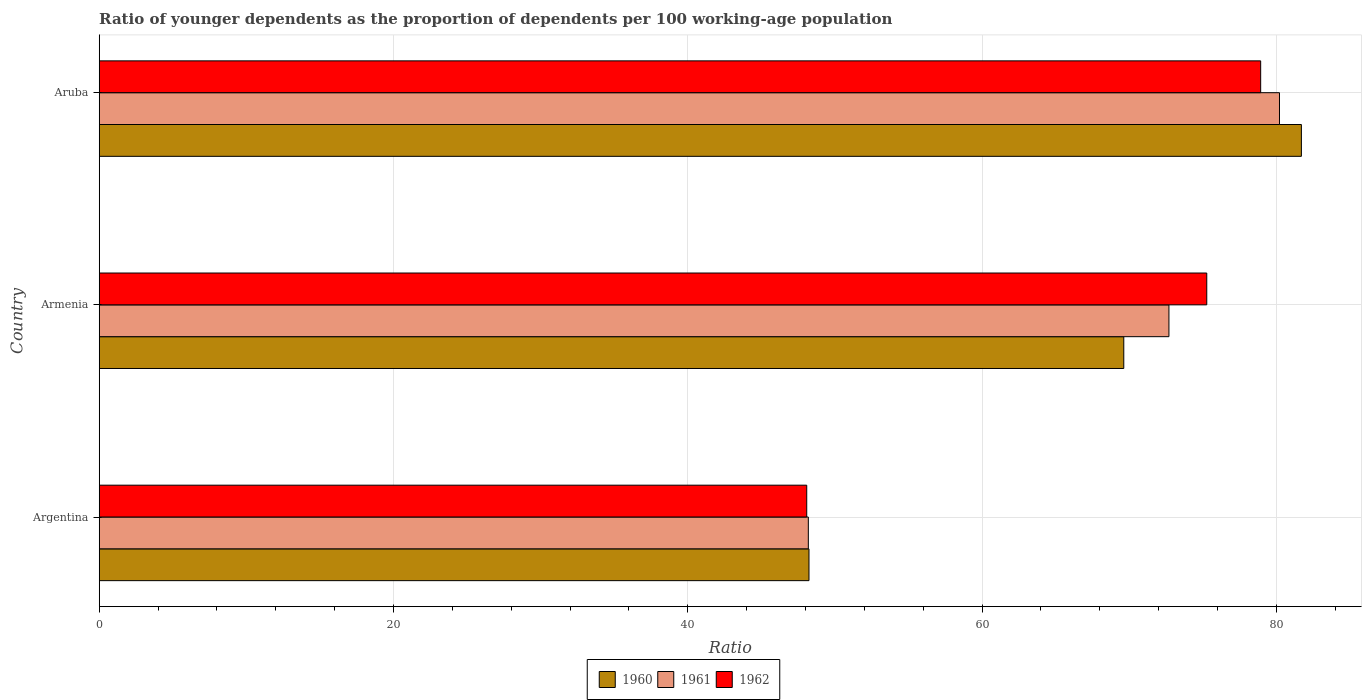How many groups of bars are there?
Your answer should be compact. 3. Are the number of bars on each tick of the Y-axis equal?
Provide a short and direct response. Yes. What is the label of the 3rd group of bars from the top?
Offer a very short reply. Argentina. In how many cases, is the number of bars for a given country not equal to the number of legend labels?
Keep it short and to the point. 0. What is the age dependency ratio(young) in 1962 in Argentina?
Offer a terse response. 48.09. Across all countries, what is the maximum age dependency ratio(young) in 1960?
Ensure brevity in your answer.  81.7. Across all countries, what is the minimum age dependency ratio(young) in 1961?
Your response must be concise. 48.19. In which country was the age dependency ratio(young) in 1961 maximum?
Give a very brief answer. Aruba. What is the total age dependency ratio(young) in 1960 in the graph?
Ensure brevity in your answer.  199.57. What is the difference between the age dependency ratio(young) in 1960 in Argentina and that in Aruba?
Ensure brevity in your answer.  -33.46. What is the difference between the age dependency ratio(young) in 1962 in Argentina and the age dependency ratio(young) in 1961 in Aruba?
Offer a terse response. -32.13. What is the average age dependency ratio(young) in 1961 per country?
Your answer should be very brief. 67.04. What is the difference between the age dependency ratio(young) in 1961 and age dependency ratio(young) in 1962 in Armenia?
Offer a terse response. -2.57. In how many countries, is the age dependency ratio(young) in 1961 greater than 68 ?
Give a very brief answer. 2. What is the ratio of the age dependency ratio(young) in 1961 in Argentina to that in Armenia?
Your response must be concise. 0.66. Is the age dependency ratio(young) in 1961 in Argentina less than that in Armenia?
Your response must be concise. Yes. Is the difference between the age dependency ratio(young) in 1961 in Argentina and Aruba greater than the difference between the age dependency ratio(young) in 1962 in Argentina and Aruba?
Keep it short and to the point. No. What is the difference between the highest and the second highest age dependency ratio(young) in 1960?
Provide a short and direct response. 12.07. What is the difference between the highest and the lowest age dependency ratio(young) in 1962?
Give a very brief answer. 30.85. Is the sum of the age dependency ratio(young) in 1962 in Argentina and Armenia greater than the maximum age dependency ratio(young) in 1960 across all countries?
Provide a succinct answer. Yes. What does the 3rd bar from the top in Argentina represents?
Offer a terse response. 1960. How many bars are there?
Your answer should be compact. 9. Are all the bars in the graph horizontal?
Your response must be concise. Yes. Does the graph contain any zero values?
Your answer should be compact. No. Where does the legend appear in the graph?
Your answer should be very brief. Bottom center. How are the legend labels stacked?
Give a very brief answer. Horizontal. What is the title of the graph?
Keep it short and to the point. Ratio of younger dependents as the proportion of dependents per 100 working-age population. Does "1994" appear as one of the legend labels in the graph?
Offer a very short reply. No. What is the label or title of the X-axis?
Offer a very short reply. Ratio. What is the label or title of the Y-axis?
Make the answer very short. Country. What is the Ratio of 1960 in Argentina?
Keep it short and to the point. 48.24. What is the Ratio of 1961 in Argentina?
Your response must be concise. 48.19. What is the Ratio of 1962 in Argentina?
Provide a succinct answer. 48.09. What is the Ratio in 1960 in Armenia?
Your answer should be very brief. 69.63. What is the Ratio of 1961 in Armenia?
Make the answer very short. 72.7. What is the Ratio of 1962 in Armenia?
Provide a succinct answer. 75.27. What is the Ratio of 1960 in Aruba?
Give a very brief answer. 81.7. What is the Ratio of 1961 in Aruba?
Your response must be concise. 80.21. What is the Ratio of 1962 in Aruba?
Make the answer very short. 78.94. Across all countries, what is the maximum Ratio in 1960?
Offer a very short reply. 81.7. Across all countries, what is the maximum Ratio in 1961?
Provide a short and direct response. 80.21. Across all countries, what is the maximum Ratio in 1962?
Your answer should be compact. 78.94. Across all countries, what is the minimum Ratio in 1960?
Ensure brevity in your answer.  48.24. Across all countries, what is the minimum Ratio in 1961?
Offer a terse response. 48.19. Across all countries, what is the minimum Ratio of 1962?
Provide a short and direct response. 48.09. What is the total Ratio of 1960 in the graph?
Offer a very short reply. 199.57. What is the total Ratio of 1961 in the graph?
Ensure brevity in your answer.  201.11. What is the total Ratio in 1962 in the graph?
Make the answer very short. 202.29. What is the difference between the Ratio in 1960 in Argentina and that in Armenia?
Offer a very short reply. -21.39. What is the difference between the Ratio of 1961 in Argentina and that in Armenia?
Make the answer very short. -24.51. What is the difference between the Ratio of 1962 in Argentina and that in Armenia?
Provide a succinct answer. -27.19. What is the difference between the Ratio in 1960 in Argentina and that in Aruba?
Ensure brevity in your answer.  -33.46. What is the difference between the Ratio of 1961 in Argentina and that in Aruba?
Provide a short and direct response. -32.02. What is the difference between the Ratio in 1962 in Argentina and that in Aruba?
Ensure brevity in your answer.  -30.85. What is the difference between the Ratio in 1960 in Armenia and that in Aruba?
Offer a terse response. -12.07. What is the difference between the Ratio in 1961 in Armenia and that in Aruba?
Keep it short and to the point. -7.51. What is the difference between the Ratio of 1962 in Armenia and that in Aruba?
Provide a short and direct response. -3.66. What is the difference between the Ratio of 1960 in Argentina and the Ratio of 1961 in Armenia?
Keep it short and to the point. -24.46. What is the difference between the Ratio of 1960 in Argentina and the Ratio of 1962 in Armenia?
Your answer should be very brief. -27.03. What is the difference between the Ratio in 1961 in Argentina and the Ratio in 1962 in Armenia?
Ensure brevity in your answer.  -27.08. What is the difference between the Ratio of 1960 in Argentina and the Ratio of 1961 in Aruba?
Keep it short and to the point. -31.98. What is the difference between the Ratio in 1960 in Argentina and the Ratio in 1962 in Aruba?
Your answer should be very brief. -30.7. What is the difference between the Ratio in 1961 in Argentina and the Ratio in 1962 in Aruba?
Provide a succinct answer. -30.74. What is the difference between the Ratio in 1960 in Armenia and the Ratio in 1961 in Aruba?
Your answer should be compact. -10.58. What is the difference between the Ratio of 1960 in Armenia and the Ratio of 1962 in Aruba?
Your answer should be very brief. -9.3. What is the difference between the Ratio of 1961 in Armenia and the Ratio of 1962 in Aruba?
Your answer should be compact. -6.23. What is the average Ratio of 1960 per country?
Provide a short and direct response. 66.52. What is the average Ratio of 1961 per country?
Your answer should be very brief. 67.04. What is the average Ratio in 1962 per country?
Keep it short and to the point. 67.43. What is the difference between the Ratio in 1960 and Ratio in 1961 in Argentina?
Offer a very short reply. 0.04. What is the difference between the Ratio in 1960 and Ratio in 1962 in Argentina?
Your response must be concise. 0.15. What is the difference between the Ratio of 1961 and Ratio of 1962 in Argentina?
Make the answer very short. 0.11. What is the difference between the Ratio of 1960 and Ratio of 1961 in Armenia?
Keep it short and to the point. -3.07. What is the difference between the Ratio in 1960 and Ratio in 1962 in Armenia?
Your response must be concise. -5.64. What is the difference between the Ratio of 1961 and Ratio of 1962 in Armenia?
Your response must be concise. -2.57. What is the difference between the Ratio in 1960 and Ratio in 1961 in Aruba?
Provide a succinct answer. 1.49. What is the difference between the Ratio in 1960 and Ratio in 1962 in Aruba?
Offer a very short reply. 2.77. What is the difference between the Ratio of 1961 and Ratio of 1962 in Aruba?
Make the answer very short. 1.28. What is the ratio of the Ratio in 1960 in Argentina to that in Armenia?
Give a very brief answer. 0.69. What is the ratio of the Ratio of 1961 in Argentina to that in Armenia?
Give a very brief answer. 0.66. What is the ratio of the Ratio of 1962 in Argentina to that in Armenia?
Give a very brief answer. 0.64. What is the ratio of the Ratio of 1960 in Argentina to that in Aruba?
Your response must be concise. 0.59. What is the ratio of the Ratio of 1961 in Argentina to that in Aruba?
Your answer should be compact. 0.6. What is the ratio of the Ratio in 1962 in Argentina to that in Aruba?
Offer a terse response. 0.61. What is the ratio of the Ratio of 1960 in Armenia to that in Aruba?
Your answer should be compact. 0.85. What is the ratio of the Ratio of 1961 in Armenia to that in Aruba?
Give a very brief answer. 0.91. What is the ratio of the Ratio in 1962 in Armenia to that in Aruba?
Provide a succinct answer. 0.95. What is the difference between the highest and the second highest Ratio of 1960?
Your answer should be very brief. 12.07. What is the difference between the highest and the second highest Ratio in 1961?
Offer a very short reply. 7.51. What is the difference between the highest and the second highest Ratio in 1962?
Give a very brief answer. 3.66. What is the difference between the highest and the lowest Ratio of 1960?
Ensure brevity in your answer.  33.46. What is the difference between the highest and the lowest Ratio in 1961?
Your answer should be compact. 32.02. What is the difference between the highest and the lowest Ratio in 1962?
Your answer should be very brief. 30.85. 